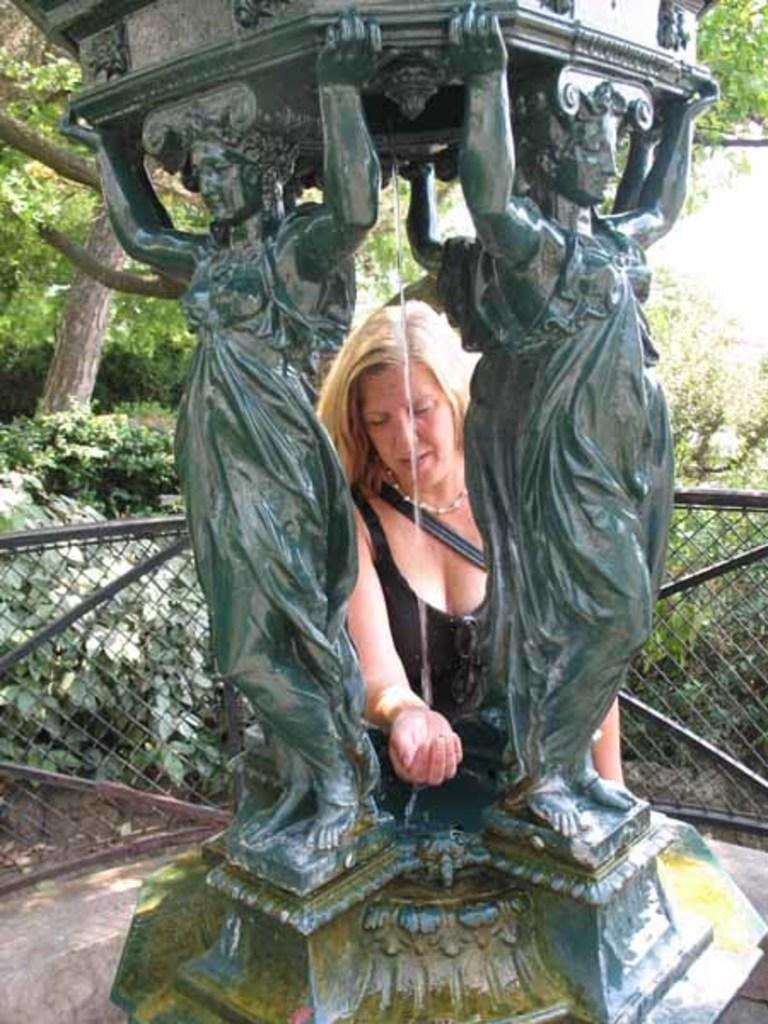What is located in the foreground of the picture? There is a sculpture and a woman in the foreground of the picture. What else can be seen in the foreground of the picture? There is a railing in the foreground of the picture. What is visible in the middle of the picture? There are plants and trees in the middle of the picture. How many pets are visible in the picture? There are no pets visible in the picture. What type of yam is being used to create the sculpture in the picture? There is no yam present in the picture; it is a sculpture made of a different material. 